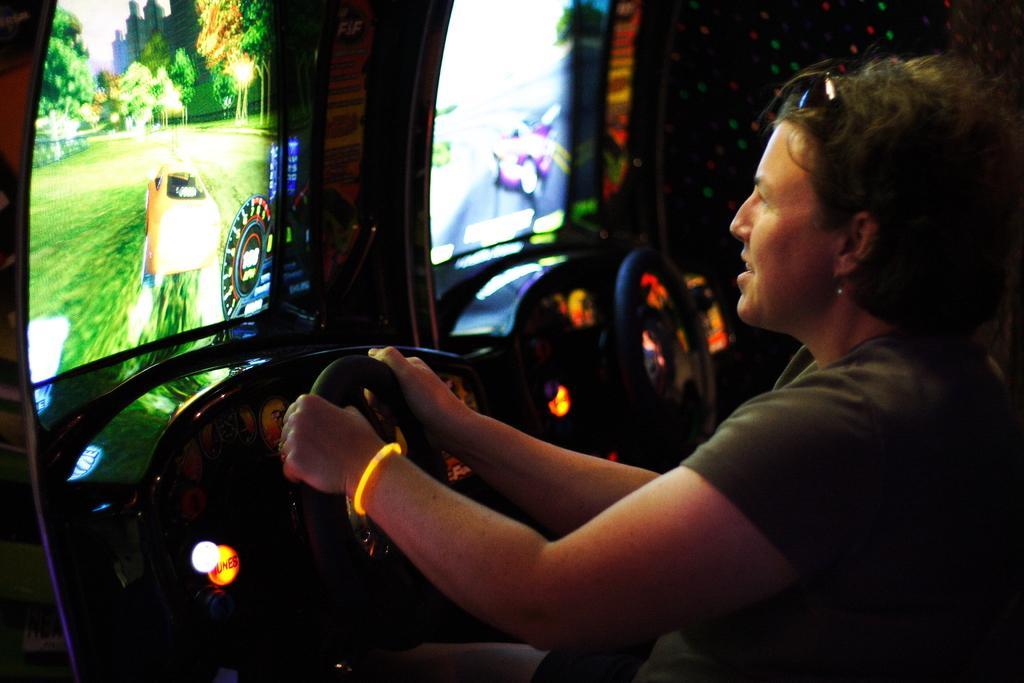Could you give a brief overview of what you see in this image? In this image we can see a woman holding the steering with her hand. We can also see some screens and lights. 